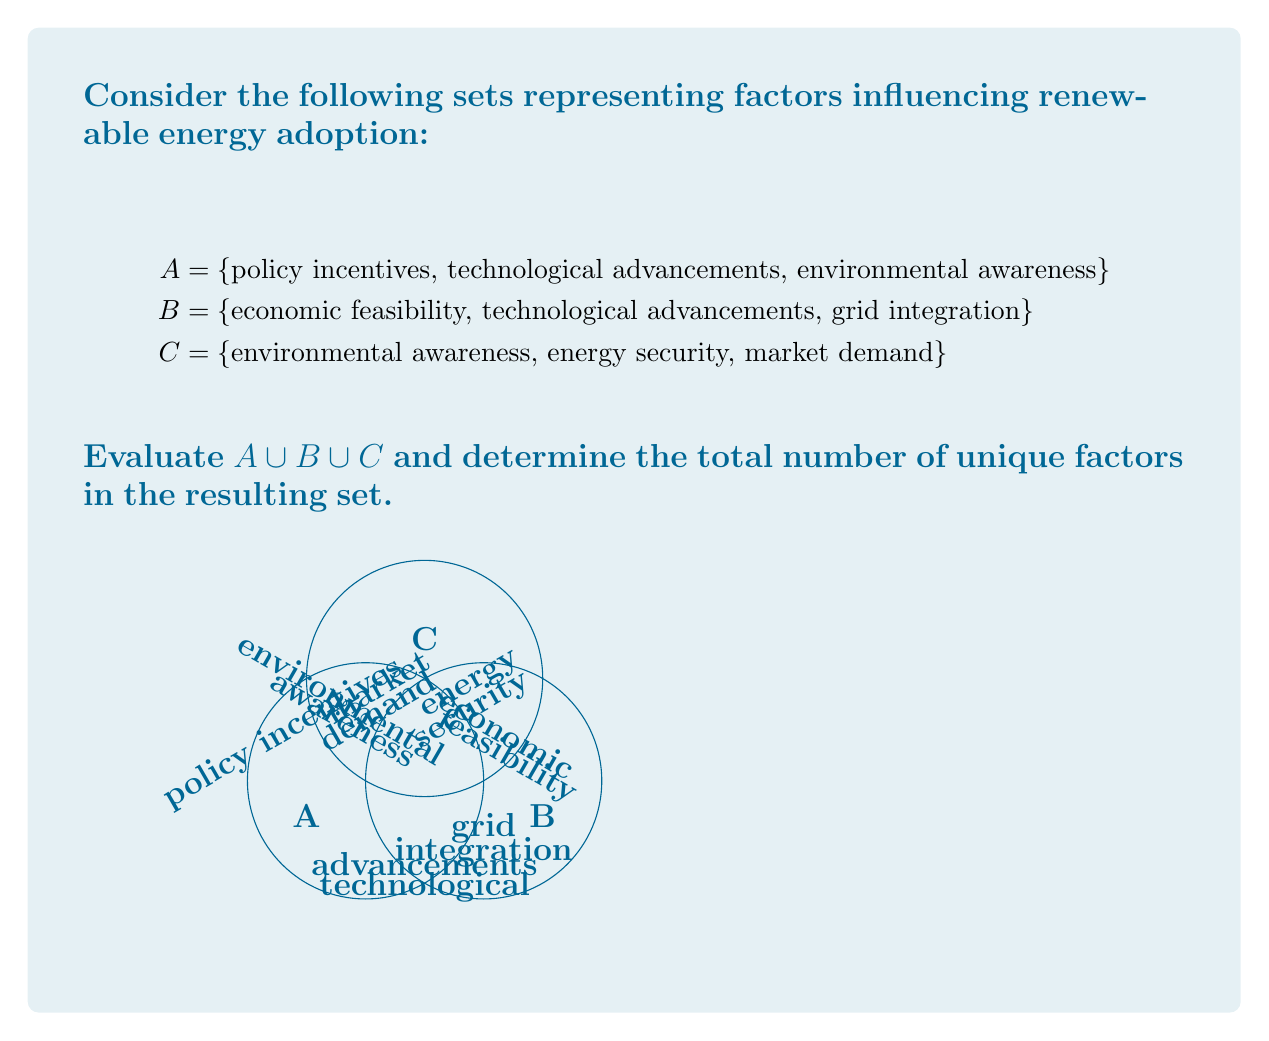Teach me how to tackle this problem. To evaluate $A \cup B \cup C$, we need to identify all unique elements across the three sets:

1. List all elements from set A:
   - policy incentives
   - technological advancements
   - environmental awareness

2. Add unique elements from set B:
   - economic feasibility
   - grid integration
   (technological advancements is already included)

3. Add unique elements from set C:
   - energy security
   - market demand
   (environmental awareness is already included)

4. Compile the union of all three sets:
   $A \cup B \cup C$ = {policy incentives, technological advancements, environmental awareness, economic feasibility, grid integration, energy security, market demand}

5. Count the number of elements in the resulting set:
   There are 7 unique factors in the union of A, B, and C.

This union represents a comprehensive set of factors influencing renewable energy adoption, combining policy, technological, environmental, economic, and market aspects.
Answer: 7 